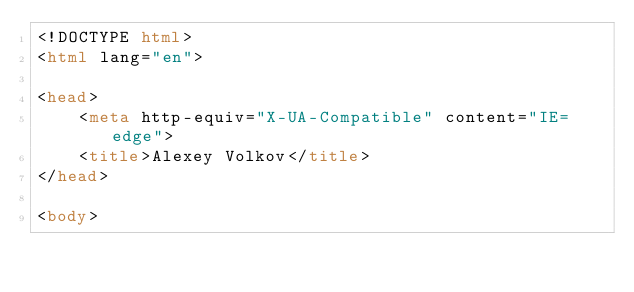<code> <loc_0><loc_0><loc_500><loc_500><_HTML_><!DOCTYPE html>
<html lang="en">

<head>
    <meta http-equiv="X-UA-Compatible" content="IE=edge">
    <title>Alexey Volkov</title>
</head>

<body></code> 